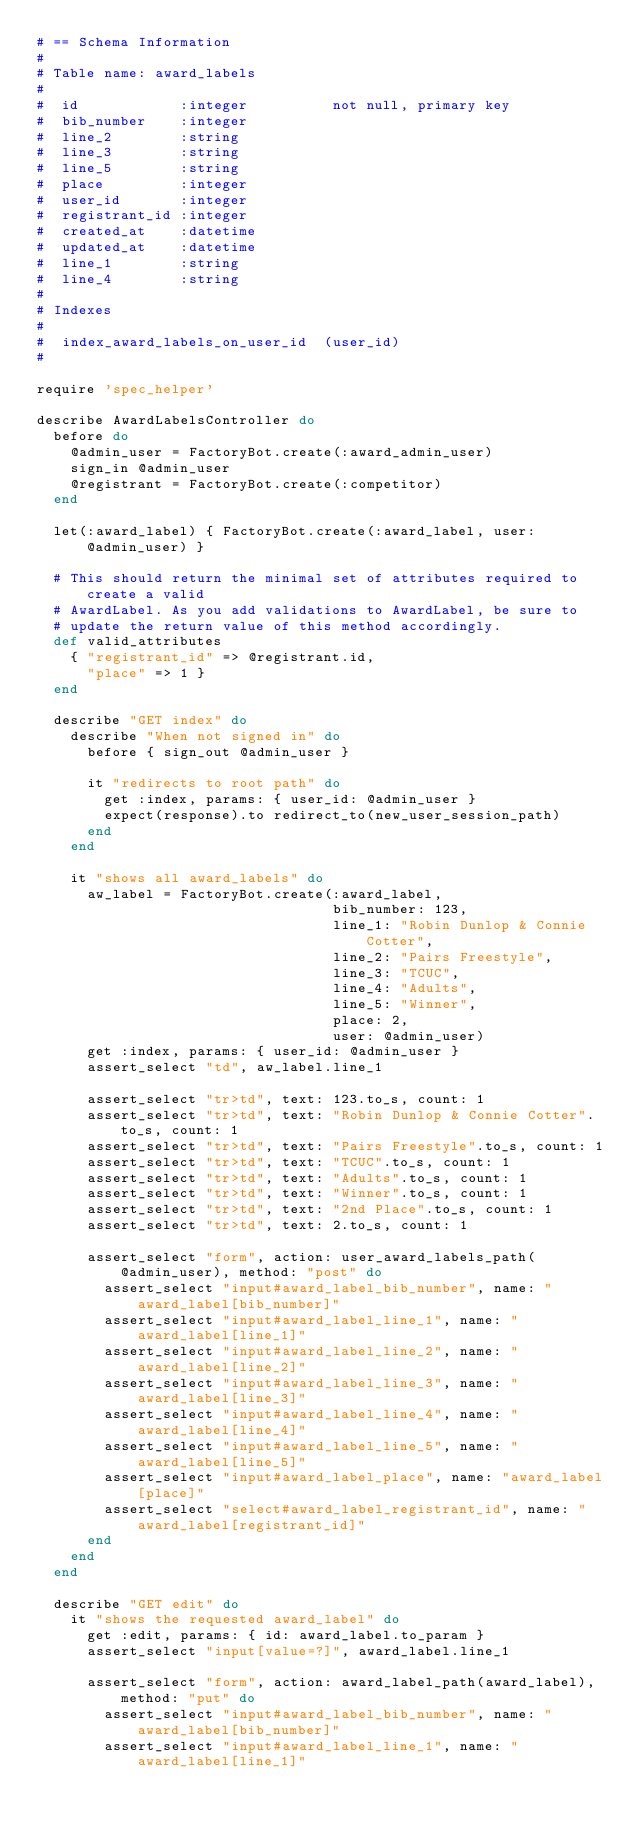<code> <loc_0><loc_0><loc_500><loc_500><_Ruby_># == Schema Information
#
# Table name: award_labels
#
#  id            :integer          not null, primary key
#  bib_number    :integer
#  line_2        :string
#  line_3        :string
#  line_5        :string
#  place         :integer
#  user_id       :integer
#  registrant_id :integer
#  created_at    :datetime
#  updated_at    :datetime
#  line_1        :string
#  line_4        :string
#
# Indexes
#
#  index_award_labels_on_user_id  (user_id)
#

require 'spec_helper'

describe AwardLabelsController do
  before do
    @admin_user = FactoryBot.create(:award_admin_user)
    sign_in @admin_user
    @registrant = FactoryBot.create(:competitor)
  end

  let(:award_label) { FactoryBot.create(:award_label, user: @admin_user) }

  # This should return the minimal set of attributes required to create a valid
  # AwardLabel. As you add validations to AwardLabel, be sure to
  # update the return value of this method accordingly.
  def valid_attributes
    { "registrant_id" => @registrant.id,
      "place" => 1 }
  end

  describe "GET index" do
    describe "When not signed in" do
      before { sign_out @admin_user }

      it "redirects to root path" do
        get :index, params: { user_id: @admin_user }
        expect(response).to redirect_to(new_user_session_path)
      end
    end

    it "shows all award_labels" do
      aw_label = FactoryBot.create(:award_label,
                                   bib_number: 123,
                                   line_1: "Robin Dunlop & Connie Cotter",
                                   line_2: "Pairs Freestyle",
                                   line_3: "TCUC",
                                   line_4: "Adults",
                                   line_5: "Winner",
                                   place: 2,
                                   user: @admin_user)
      get :index, params: { user_id: @admin_user }
      assert_select "td", aw_label.line_1

      assert_select "tr>td", text: 123.to_s, count: 1
      assert_select "tr>td", text: "Robin Dunlop & Connie Cotter".to_s, count: 1
      assert_select "tr>td", text: "Pairs Freestyle".to_s, count: 1
      assert_select "tr>td", text: "TCUC".to_s, count: 1
      assert_select "tr>td", text: "Adults".to_s, count: 1
      assert_select "tr>td", text: "Winner".to_s, count: 1
      assert_select "tr>td", text: "2nd Place".to_s, count: 1
      assert_select "tr>td", text: 2.to_s, count: 1

      assert_select "form", action: user_award_labels_path(@admin_user), method: "post" do
        assert_select "input#award_label_bib_number", name: "award_label[bib_number]"
        assert_select "input#award_label_line_1", name: "award_label[line_1]"
        assert_select "input#award_label_line_2", name: "award_label[line_2]"
        assert_select "input#award_label_line_3", name: "award_label[line_3]"
        assert_select "input#award_label_line_4", name: "award_label[line_4]"
        assert_select "input#award_label_line_5", name: "award_label[line_5]"
        assert_select "input#award_label_place", name: "award_label[place]"
        assert_select "select#award_label_registrant_id", name: "award_label[registrant_id]"
      end
    end
  end

  describe "GET edit" do
    it "shows the requested award_label" do
      get :edit, params: { id: award_label.to_param }
      assert_select "input[value=?]", award_label.line_1

      assert_select "form", action: award_label_path(award_label), method: "put" do
        assert_select "input#award_label_bib_number", name: "award_label[bib_number]"
        assert_select "input#award_label_line_1", name: "award_label[line_1]"</code> 